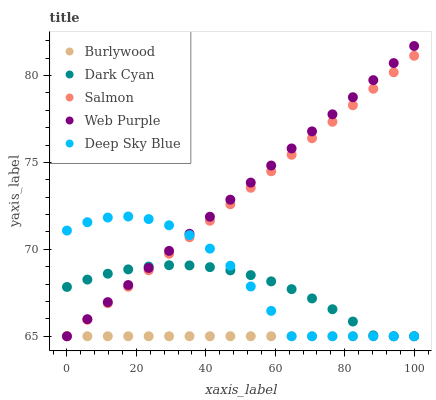Does Burlywood have the minimum area under the curve?
Answer yes or no. Yes. Does Web Purple have the maximum area under the curve?
Answer yes or no. Yes. Does Dark Cyan have the minimum area under the curve?
Answer yes or no. No. Does Dark Cyan have the maximum area under the curve?
Answer yes or no. No. Is Web Purple the smoothest?
Answer yes or no. Yes. Is Deep Sky Blue the roughest?
Answer yes or no. Yes. Is Dark Cyan the smoothest?
Answer yes or no. No. Is Dark Cyan the roughest?
Answer yes or no. No. Does Burlywood have the lowest value?
Answer yes or no. Yes. Does Web Purple have the highest value?
Answer yes or no. Yes. Does Dark Cyan have the highest value?
Answer yes or no. No. Does Dark Cyan intersect Salmon?
Answer yes or no. Yes. Is Dark Cyan less than Salmon?
Answer yes or no. No. Is Dark Cyan greater than Salmon?
Answer yes or no. No. 